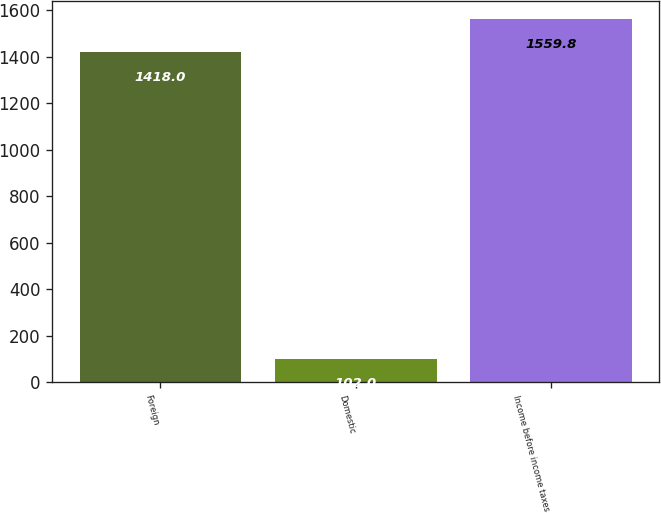Convert chart to OTSL. <chart><loc_0><loc_0><loc_500><loc_500><bar_chart><fcel>Foreign<fcel>Domestic<fcel>Income before income taxes<nl><fcel>1418<fcel>102<fcel>1559.8<nl></chart> 